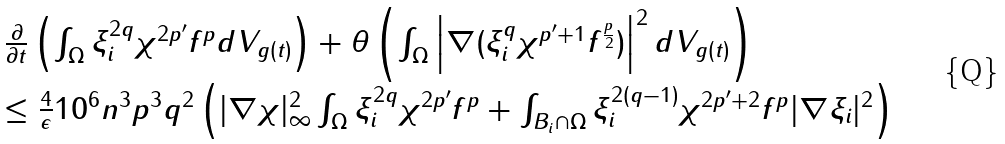<formula> <loc_0><loc_0><loc_500><loc_500>{ \begin{array} { r l } & \frac { \partial } { \partial t } \left ( \int _ { \Omega } \xi _ { i } ^ { 2 q } \chi ^ { 2 p ^ { \prime } } f ^ { p } d V _ { g ( t ) } \right ) + \theta \left ( \int _ { \Omega } \left | \nabla ( \xi _ { i } ^ { q } \chi ^ { p ^ { \prime } + 1 } f ^ { \frac { p } { 2 } } ) \right | ^ { 2 } d V _ { g ( t ) } \right ) \\ & \leq \frac { 4 } { \epsilon } 1 0 ^ { 6 } n ^ { 3 } p ^ { 3 } q ^ { 2 } \left ( | \nabla \chi | _ { \infty } ^ { 2 } \int _ { \Omega } \xi _ { i } ^ { 2 q } \chi ^ { 2 p ^ { \prime } } f ^ { p } + \int _ { B _ { i } \cap \Omega } \xi _ { i } ^ { 2 ( q - 1 ) } \chi ^ { 2 p ^ { \prime } + 2 } f ^ { p } | \nabla \xi _ { i } | ^ { 2 } \right ) \end{array} }</formula> 